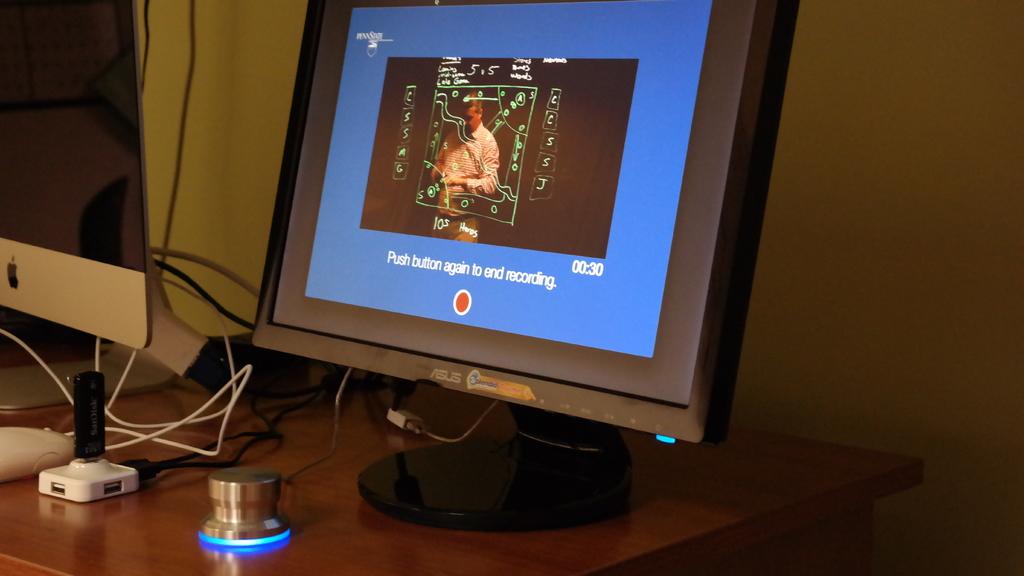What do you have to do to end recording?
Keep it short and to the point. Push button again. What are you doing the computer?
Offer a terse response. Recording. 